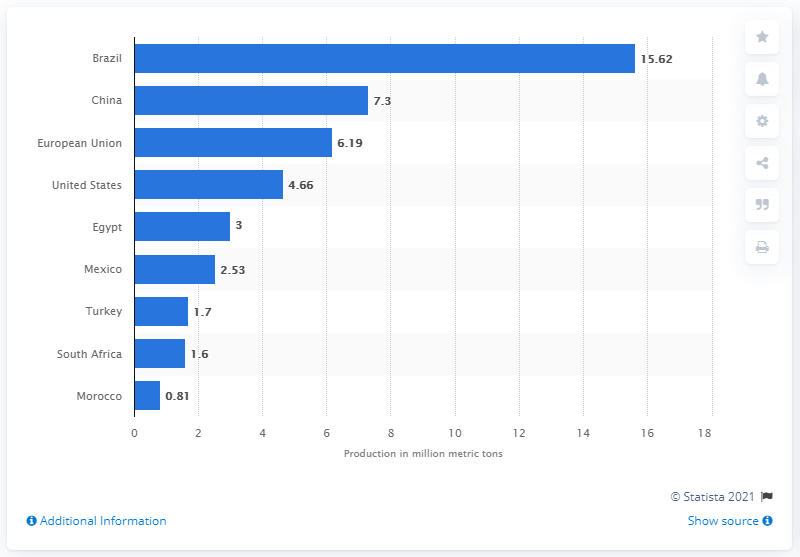Mention a couple of crucial points in this snapshot. The production volume of Brazil's oranges in 2019/2020 was 15,620 million units. Brazil was the leading global producer of oranges in the 2019/2020 season. 